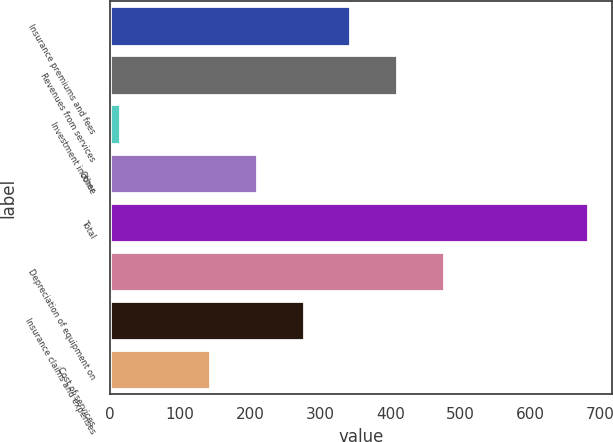Convert chart. <chart><loc_0><loc_0><loc_500><loc_500><bar_chart><fcel>Insurance premiums and fees<fcel>Revenues from services<fcel>Investment income<fcel>Other<fcel>Total<fcel>Depreciation of equipment on<fcel>Insurance claims and expenses<fcel>Cost of services<nl><fcel>343.1<fcel>409.8<fcel>15<fcel>209.7<fcel>682<fcel>476.5<fcel>276.4<fcel>143<nl></chart> 